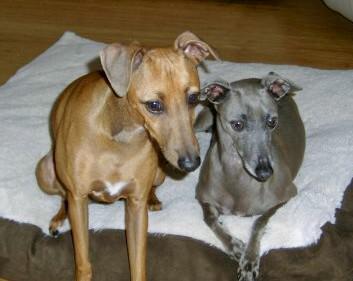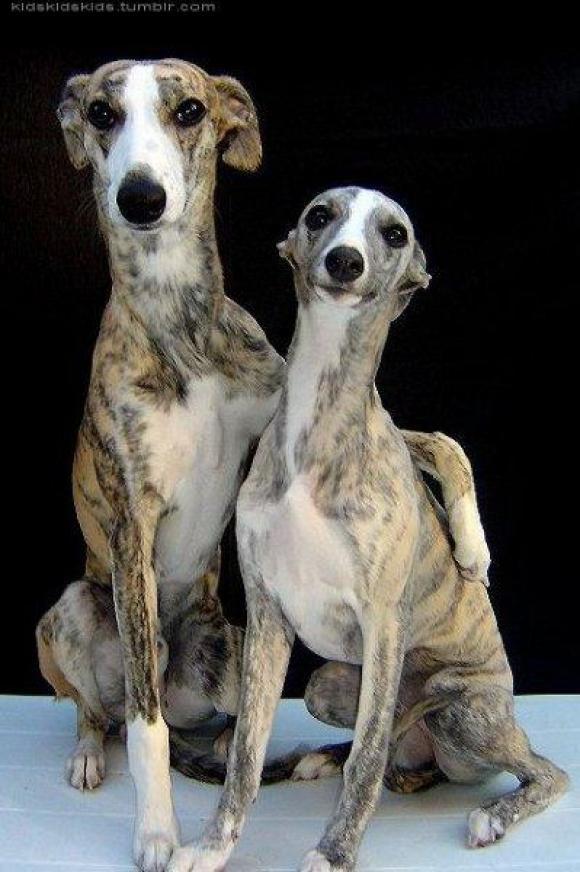The first image is the image on the left, the second image is the image on the right. Assess this claim about the two images: "The dogs in the image on the right are standing on a tiled floor.". Correct or not? Answer yes or no. No. The first image is the image on the left, the second image is the image on the right. For the images displayed, is the sentence "Two hounds of different colors are side-by-side on a soft surface, and at least one dog is reclining." factually correct? Answer yes or no. Yes. 